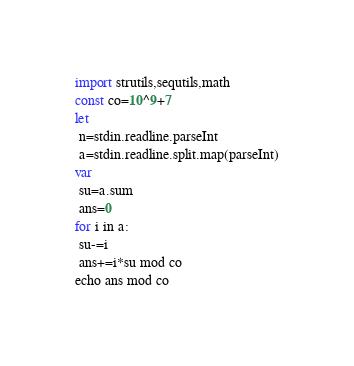Convert code to text. <code><loc_0><loc_0><loc_500><loc_500><_Nim_>import strutils,sequtils,math
const co=10^9+7
let
 n=stdin.readline.parseInt
 a=stdin.readline.split.map(parseInt)
var
 su=a.sum
 ans=0
for i in a:
 su-=i
 ans+=i*su mod co
echo ans mod co
</code> 